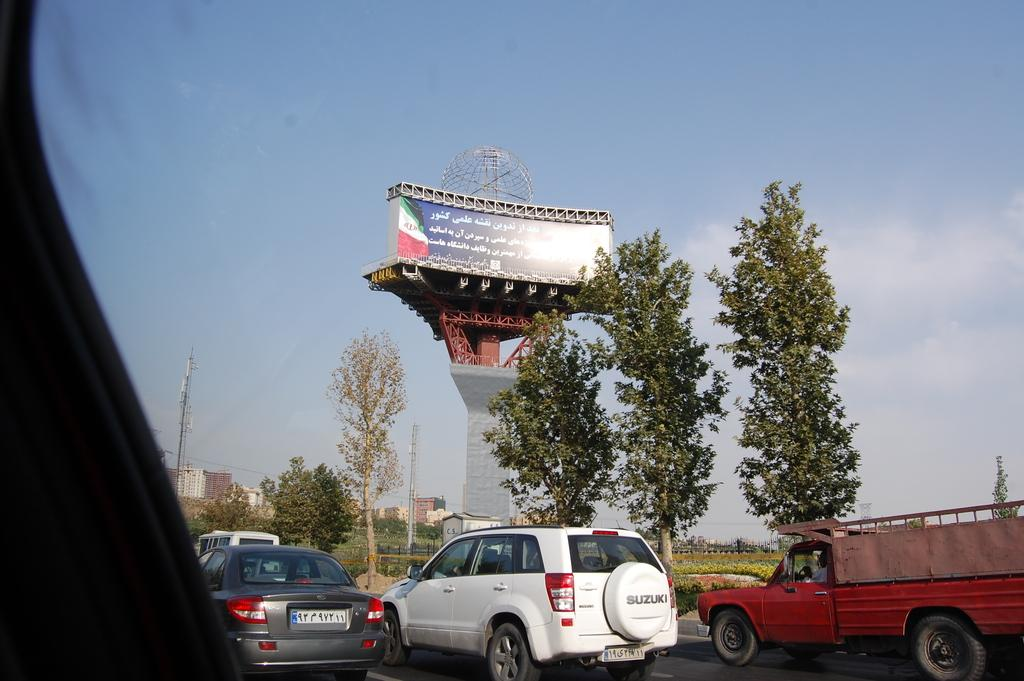What types of objects can be seen in the image? There are vehicles, trees, buildings, and towers in the image. What is the color of the trees in the image? The trees in the image have green color. What is the color of the sky in the image? The sky is blue and white in color. How many times does the number 7 appear in the image? There is no mention of the number 7 in the image, so it cannot be determined how many times it appears. What type of self-driving vehicle can be seen in the image? There is no self-driving vehicle present in the image. 